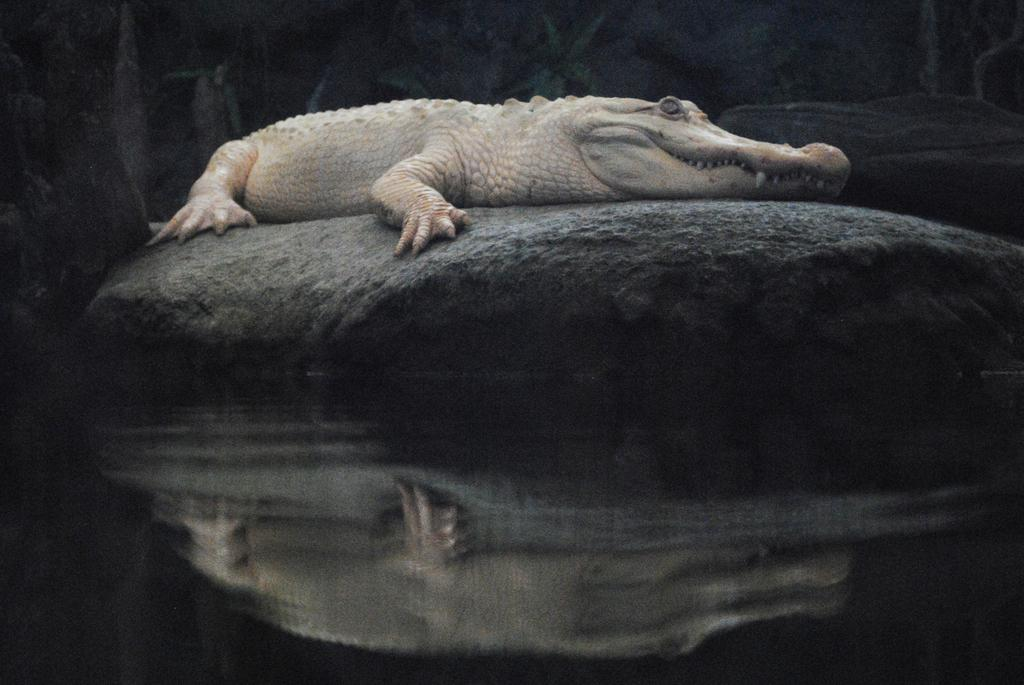What animal is present in the image? There is a crocodile in the image. Where is the crocodile located? The crocodile is on the rocks. What can be seen at the bottom of the image? There is water visible at the bottom of the image. What type of soup is being served in the image? There is no soup present in the image; it features a crocodile on rocks with water below. 